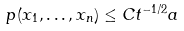<formula> <loc_0><loc_0><loc_500><loc_500>p ( x _ { 1 } , \dots , x _ { n } ) \leq C t ^ { - 1 / 2 } a</formula> 